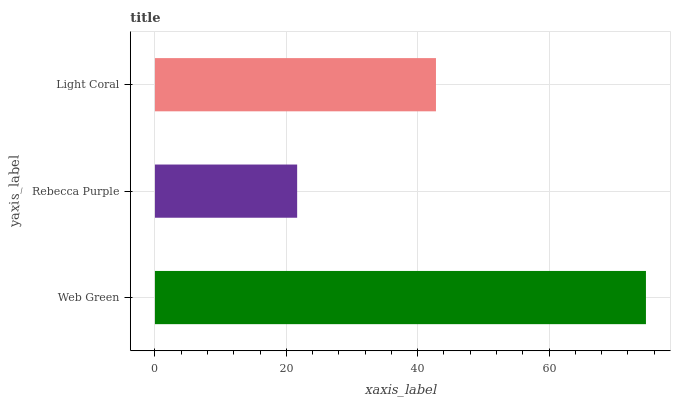Is Rebecca Purple the minimum?
Answer yes or no. Yes. Is Web Green the maximum?
Answer yes or no. Yes. Is Light Coral the minimum?
Answer yes or no. No. Is Light Coral the maximum?
Answer yes or no. No. Is Light Coral greater than Rebecca Purple?
Answer yes or no. Yes. Is Rebecca Purple less than Light Coral?
Answer yes or no. Yes. Is Rebecca Purple greater than Light Coral?
Answer yes or no. No. Is Light Coral less than Rebecca Purple?
Answer yes or no. No. Is Light Coral the high median?
Answer yes or no. Yes. Is Light Coral the low median?
Answer yes or no. Yes. Is Rebecca Purple the high median?
Answer yes or no. No. Is Rebecca Purple the low median?
Answer yes or no. No. 